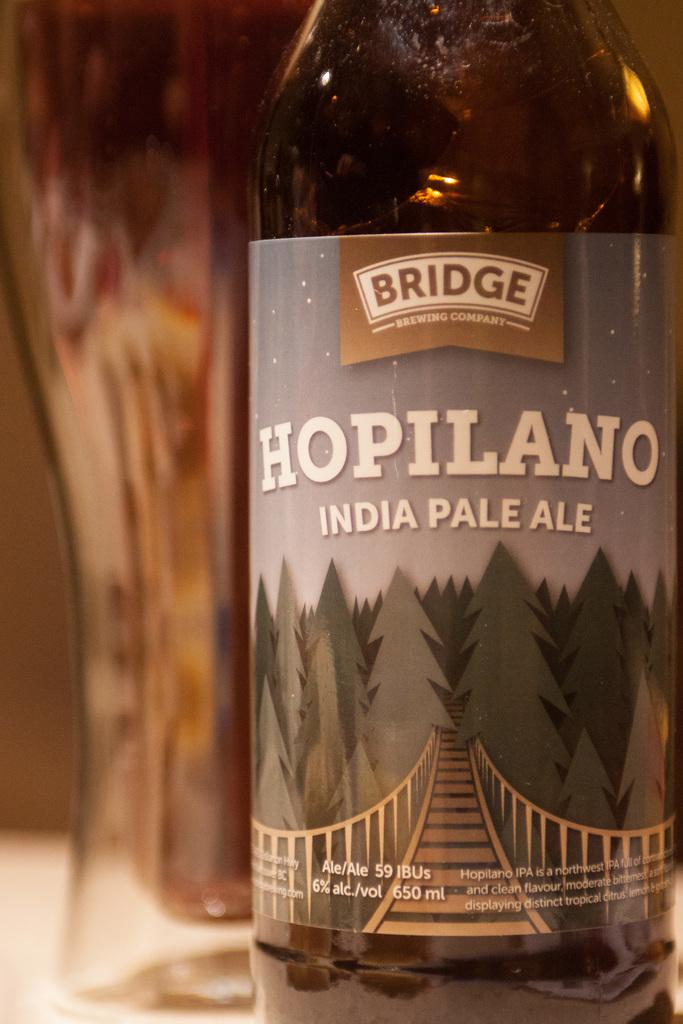<image>
Describe the image concisely. A bottle of Hopilano India Pale Ale sits on the table. 